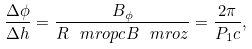<formula> <loc_0><loc_0><loc_500><loc_500>\frac { \Delta \phi } { \Delta h } = \frac { B _ { \phi } } { R _ { \ } m r o { p c } B _ { \ } m r o { z } } = \frac { 2 \pi } { P _ { 1 } c } ,</formula> 